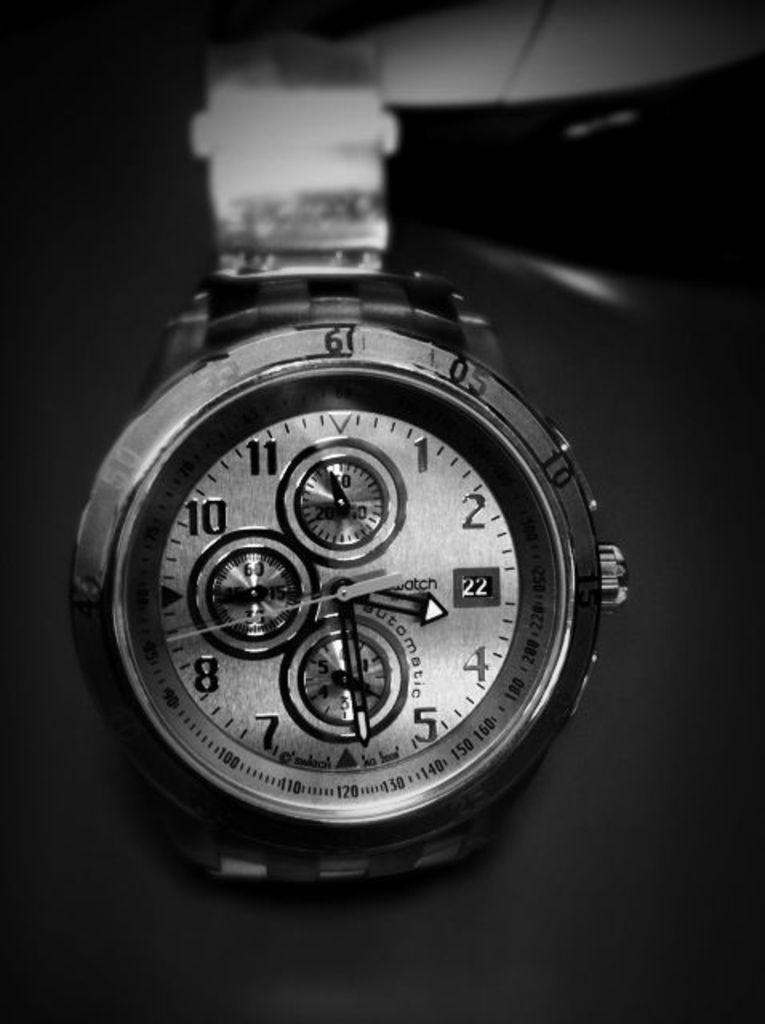<image>
Summarize the visual content of the image. The steel watch displays a time of 3:29. 